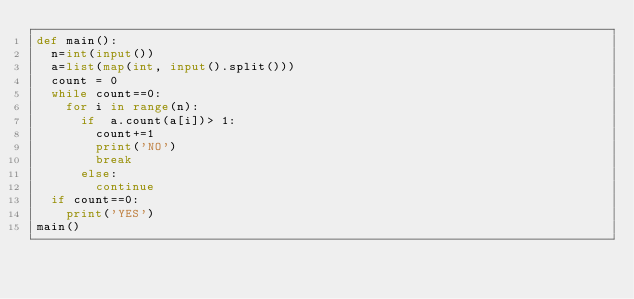Convert code to text. <code><loc_0><loc_0><loc_500><loc_500><_Python_>def main():
	n=int(input())
	a=list(map(int, input().split()))
	count = 0
	while count==0:
		for i in range(n):
			if  a.count(a[i])> 1:
				count+=1
				print('NO')
				break
			else:
				continue
	if count==0:
		print('YES')
main()</code> 